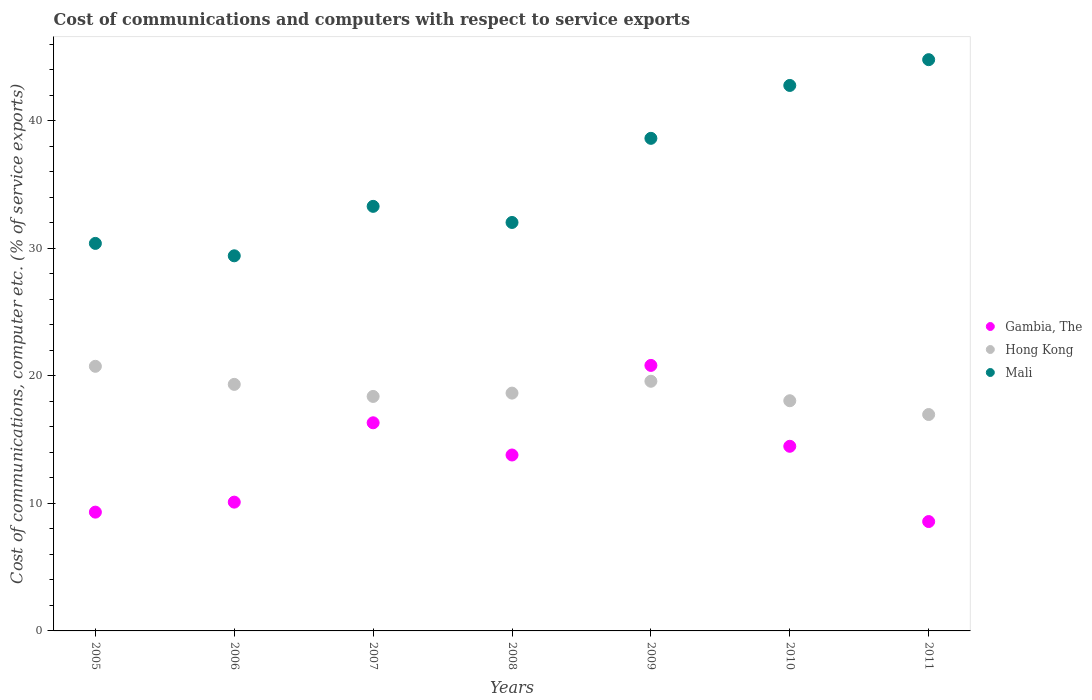How many different coloured dotlines are there?
Your answer should be very brief. 3. Is the number of dotlines equal to the number of legend labels?
Your answer should be very brief. Yes. What is the cost of communications and computers in Mali in 2008?
Offer a very short reply. 32.04. Across all years, what is the maximum cost of communications and computers in Gambia, The?
Give a very brief answer. 20.83. Across all years, what is the minimum cost of communications and computers in Gambia, The?
Offer a terse response. 8.58. In which year was the cost of communications and computers in Gambia, The maximum?
Provide a succinct answer. 2009. What is the total cost of communications and computers in Mali in the graph?
Make the answer very short. 251.39. What is the difference between the cost of communications and computers in Gambia, The in 2005 and that in 2009?
Offer a very short reply. -11.51. What is the difference between the cost of communications and computers in Hong Kong in 2006 and the cost of communications and computers in Gambia, The in 2011?
Provide a short and direct response. 10.76. What is the average cost of communications and computers in Hong Kong per year?
Offer a terse response. 18.82. In the year 2009, what is the difference between the cost of communications and computers in Gambia, The and cost of communications and computers in Hong Kong?
Keep it short and to the point. 1.24. What is the ratio of the cost of communications and computers in Hong Kong in 2007 to that in 2011?
Ensure brevity in your answer.  1.08. Is the cost of communications and computers in Gambia, The in 2008 less than that in 2011?
Provide a succinct answer. No. What is the difference between the highest and the second highest cost of communications and computers in Gambia, The?
Give a very brief answer. 4.5. What is the difference between the highest and the lowest cost of communications and computers in Hong Kong?
Your answer should be compact. 3.78. Is the cost of communications and computers in Hong Kong strictly less than the cost of communications and computers in Mali over the years?
Your answer should be compact. Yes. How many years are there in the graph?
Your answer should be very brief. 7. Does the graph contain grids?
Your answer should be very brief. No. Where does the legend appear in the graph?
Ensure brevity in your answer.  Center right. How are the legend labels stacked?
Provide a succinct answer. Vertical. What is the title of the graph?
Provide a succinct answer. Cost of communications and computers with respect to service exports. What is the label or title of the Y-axis?
Ensure brevity in your answer.  Cost of communications, computer etc. (% of service exports). What is the Cost of communications, computer etc. (% of service exports) of Gambia, The in 2005?
Your response must be concise. 9.32. What is the Cost of communications, computer etc. (% of service exports) of Hong Kong in 2005?
Offer a very short reply. 20.76. What is the Cost of communications, computer etc. (% of service exports) in Mali in 2005?
Your answer should be very brief. 30.4. What is the Cost of communications, computer etc. (% of service exports) of Gambia, The in 2006?
Your answer should be very brief. 10.1. What is the Cost of communications, computer etc. (% of service exports) in Hong Kong in 2006?
Provide a succinct answer. 19.34. What is the Cost of communications, computer etc. (% of service exports) in Mali in 2006?
Make the answer very short. 29.42. What is the Cost of communications, computer etc. (% of service exports) in Gambia, The in 2007?
Provide a short and direct response. 16.33. What is the Cost of communications, computer etc. (% of service exports) of Hong Kong in 2007?
Give a very brief answer. 18.39. What is the Cost of communications, computer etc. (% of service exports) of Mali in 2007?
Offer a very short reply. 33.3. What is the Cost of communications, computer etc. (% of service exports) in Gambia, The in 2008?
Offer a very short reply. 13.8. What is the Cost of communications, computer etc. (% of service exports) in Hong Kong in 2008?
Your answer should be very brief. 18.65. What is the Cost of communications, computer etc. (% of service exports) in Mali in 2008?
Your answer should be compact. 32.04. What is the Cost of communications, computer etc. (% of service exports) of Gambia, The in 2009?
Ensure brevity in your answer.  20.83. What is the Cost of communications, computer etc. (% of service exports) of Hong Kong in 2009?
Provide a short and direct response. 19.58. What is the Cost of communications, computer etc. (% of service exports) in Mali in 2009?
Your response must be concise. 38.64. What is the Cost of communications, computer etc. (% of service exports) in Gambia, The in 2010?
Your answer should be very brief. 14.48. What is the Cost of communications, computer etc. (% of service exports) in Hong Kong in 2010?
Give a very brief answer. 18.06. What is the Cost of communications, computer etc. (% of service exports) of Mali in 2010?
Your response must be concise. 42.79. What is the Cost of communications, computer etc. (% of service exports) in Gambia, The in 2011?
Your answer should be compact. 8.58. What is the Cost of communications, computer etc. (% of service exports) of Hong Kong in 2011?
Keep it short and to the point. 16.97. What is the Cost of communications, computer etc. (% of service exports) in Mali in 2011?
Offer a terse response. 44.81. Across all years, what is the maximum Cost of communications, computer etc. (% of service exports) of Gambia, The?
Your answer should be compact. 20.83. Across all years, what is the maximum Cost of communications, computer etc. (% of service exports) of Hong Kong?
Make the answer very short. 20.76. Across all years, what is the maximum Cost of communications, computer etc. (% of service exports) of Mali?
Offer a terse response. 44.81. Across all years, what is the minimum Cost of communications, computer etc. (% of service exports) in Gambia, The?
Offer a terse response. 8.58. Across all years, what is the minimum Cost of communications, computer etc. (% of service exports) of Hong Kong?
Provide a short and direct response. 16.97. Across all years, what is the minimum Cost of communications, computer etc. (% of service exports) in Mali?
Ensure brevity in your answer.  29.42. What is the total Cost of communications, computer etc. (% of service exports) of Gambia, The in the graph?
Your answer should be very brief. 93.43. What is the total Cost of communications, computer etc. (% of service exports) in Hong Kong in the graph?
Ensure brevity in your answer.  131.75. What is the total Cost of communications, computer etc. (% of service exports) in Mali in the graph?
Your answer should be very brief. 251.39. What is the difference between the Cost of communications, computer etc. (% of service exports) in Gambia, The in 2005 and that in 2006?
Keep it short and to the point. -0.78. What is the difference between the Cost of communications, computer etc. (% of service exports) of Hong Kong in 2005 and that in 2006?
Ensure brevity in your answer.  1.42. What is the difference between the Cost of communications, computer etc. (% of service exports) in Mali in 2005 and that in 2006?
Offer a terse response. 0.97. What is the difference between the Cost of communications, computer etc. (% of service exports) of Gambia, The in 2005 and that in 2007?
Give a very brief answer. -7.01. What is the difference between the Cost of communications, computer etc. (% of service exports) in Hong Kong in 2005 and that in 2007?
Your answer should be very brief. 2.36. What is the difference between the Cost of communications, computer etc. (% of service exports) of Mali in 2005 and that in 2007?
Ensure brevity in your answer.  -2.91. What is the difference between the Cost of communications, computer etc. (% of service exports) in Gambia, The in 2005 and that in 2008?
Your answer should be very brief. -4.48. What is the difference between the Cost of communications, computer etc. (% of service exports) of Hong Kong in 2005 and that in 2008?
Provide a succinct answer. 2.1. What is the difference between the Cost of communications, computer etc. (% of service exports) in Mali in 2005 and that in 2008?
Provide a short and direct response. -1.64. What is the difference between the Cost of communications, computer etc. (% of service exports) in Gambia, The in 2005 and that in 2009?
Give a very brief answer. -11.51. What is the difference between the Cost of communications, computer etc. (% of service exports) of Hong Kong in 2005 and that in 2009?
Provide a succinct answer. 1.17. What is the difference between the Cost of communications, computer etc. (% of service exports) in Mali in 2005 and that in 2009?
Provide a succinct answer. -8.24. What is the difference between the Cost of communications, computer etc. (% of service exports) in Gambia, The in 2005 and that in 2010?
Your answer should be very brief. -5.16. What is the difference between the Cost of communications, computer etc. (% of service exports) in Hong Kong in 2005 and that in 2010?
Provide a succinct answer. 2.7. What is the difference between the Cost of communications, computer etc. (% of service exports) of Mali in 2005 and that in 2010?
Provide a short and direct response. -12.39. What is the difference between the Cost of communications, computer etc. (% of service exports) in Gambia, The in 2005 and that in 2011?
Provide a succinct answer. 0.74. What is the difference between the Cost of communications, computer etc. (% of service exports) in Hong Kong in 2005 and that in 2011?
Offer a terse response. 3.78. What is the difference between the Cost of communications, computer etc. (% of service exports) of Mali in 2005 and that in 2011?
Your answer should be very brief. -14.41. What is the difference between the Cost of communications, computer etc. (% of service exports) of Gambia, The in 2006 and that in 2007?
Keep it short and to the point. -6.22. What is the difference between the Cost of communications, computer etc. (% of service exports) in Hong Kong in 2006 and that in 2007?
Your answer should be very brief. 0.95. What is the difference between the Cost of communications, computer etc. (% of service exports) of Mali in 2006 and that in 2007?
Provide a succinct answer. -3.88. What is the difference between the Cost of communications, computer etc. (% of service exports) of Gambia, The in 2006 and that in 2008?
Give a very brief answer. -3.7. What is the difference between the Cost of communications, computer etc. (% of service exports) in Hong Kong in 2006 and that in 2008?
Ensure brevity in your answer.  0.68. What is the difference between the Cost of communications, computer etc. (% of service exports) of Mali in 2006 and that in 2008?
Your answer should be very brief. -2.62. What is the difference between the Cost of communications, computer etc. (% of service exports) of Gambia, The in 2006 and that in 2009?
Your answer should be very brief. -10.72. What is the difference between the Cost of communications, computer etc. (% of service exports) in Hong Kong in 2006 and that in 2009?
Your answer should be very brief. -0.25. What is the difference between the Cost of communications, computer etc. (% of service exports) in Mali in 2006 and that in 2009?
Your answer should be compact. -9.21. What is the difference between the Cost of communications, computer etc. (% of service exports) in Gambia, The in 2006 and that in 2010?
Offer a very short reply. -4.38. What is the difference between the Cost of communications, computer etc. (% of service exports) of Hong Kong in 2006 and that in 2010?
Offer a terse response. 1.28. What is the difference between the Cost of communications, computer etc. (% of service exports) in Mali in 2006 and that in 2010?
Provide a succinct answer. -13.36. What is the difference between the Cost of communications, computer etc. (% of service exports) in Gambia, The in 2006 and that in 2011?
Provide a short and direct response. 1.52. What is the difference between the Cost of communications, computer etc. (% of service exports) in Hong Kong in 2006 and that in 2011?
Your answer should be very brief. 2.36. What is the difference between the Cost of communications, computer etc. (% of service exports) in Mali in 2006 and that in 2011?
Your response must be concise. -15.38. What is the difference between the Cost of communications, computer etc. (% of service exports) of Gambia, The in 2007 and that in 2008?
Give a very brief answer. 2.53. What is the difference between the Cost of communications, computer etc. (% of service exports) of Hong Kong in 2007 and that in 2008?
Give a very brief answer. -0.26. What is the difference between the Cost of communications, computer etc. (% of service exports) of Mali in 2007 and that in 2008?
Give a very brief answer. 1.26. What is the difference between the Cost of communications, computer etc. (% of service exports) in Gambia, The in 2007 and that in 2009?
Ensure brevity in your answer.  -4.5. What is the difference between the Cost of communications, computer etc. (% of service exports) in Hong Kong in 2007 and that in 2009?
Ensure brevity in your answer.  -1.19. What is the difference between the Cost of communications, computer etc. (% of service exports) of Mali in 2007 and that in 2009?
Keep it short and to the point. -5.33. What is the difference between the Cost of communications, computer etc. (% of service exports) of Gambia, The in 2007 and that in 2010?
Offer a very short reply. 1.84. What is the difference between the Cost of communications, computer etc. (% of service exports) of Hong Kong in 2007 and that in 2010?
Provide a succinct answer. 0.34. What is the difference between the Cost of communications, computer etc. (% of service exports) of Mali in 2007 and that in 2010?
Ensure brevity in your answer.  -9.48. What is the difference between the Cost of communications, computer etc. (% of service exports) of Gambia, The in 2007 and that in 2011?
Make the answer very short. 7.75. What is the difference between the Cost of communications, computer etc. (% of service exports) of Hong Kong in 2007 and that in 2011?
Make the answer very short. 1.42. What is the difference between the Cost of communications, computer etc. (% of service exports) of Mali in 2007 and that in 2011?
Provide a succinct answer. -11.51. What is the difference between the Cost of communications, computer etc. (% of service exports) of Gambia, The in 2008 and that in 2009?
Your answer should be compact. -7.03. What is the difference between the Cost of communications, computer etc. (% of service exports) of Hong Kong in 2008 and that in 2009?
Ensure brevity in your answer.  -0.93. What is the difference between the Cost of communications, computer etc. (% of service exports) in Mali in 2008 and that in 2009?
Give a very brief answer. -6.6. What is the difference between the Cost of communications, computer etc. (% of service exports) in Gambia, The in 2008 and that in 2010?
Your response must be concise. -0.68. What is the difference between the Cost of communications, computer etc. (% of service exports) of Hong Kong in 2008 and that in 2010?
Your answer should be compact. 0.6. What is the difference between the Cost of communications, computer etc. (% of service exports) in Mali in 2008 and that in 2010?
Offer a terse response. -10.75. What is the difference between the Cost of communications, computer etc. (% of service exports) in Gambia, The in 2008 and that in 2011?
Offer a terse response. 5.22. What is the difference between the Cost of communications, computer etc. (% of service exports) in Hong Kong in 2008 and that in 2011?
Your response must be concise. 1.68. What is the difference between the Cost of communications, computer etc. (% of service exports) in Mali in 2008 and that in 2011?
Give a very brief answer. -12.77. What is the difference between the Cost of communications, computer etc. (% of service exports) in Gambia, The in 2009 and that in 2010?
Keep it short and to the point. 6.34. What is the difference between the Cost of communications, computer etc. (% of service exports) of Hong Kong in 2009 and that in 2010?
Your response must be concise. 1.53. What is the difference between the Cost of communications, computer etc. (% of service exports) in Mali in 2009 and that in 2010?
Ensure brevity in your answer.  -4.15. What is the difference between the Cost of communications, computer etc. (% of service exports) in Gambia, The in 2009 and that in 2011?
Give a very brief answer. 12.25. What is the difference between the Cost of communications, computer etc. (% of service exports) in Hong Kong in 2009 and that in 2011?
Keep it short and to the point. 2.61. What is the difference between the Cost of communications, computer etc. (% of service exports) in Mali in 2009 and that in 2011?
Your answer should be compact. -6.17. What is the difference between the Cost of communications, computer etc. (% of service exports) of Gambia, The in 2010 and that in 2011?
Provide a short and direct response. 5.9. What is the difference between the Cost of communications, computer etc. (% of service exports) of Hong Kong in 2010 and that in 2011?
Provide a short and direct response. 1.08. What is the difference between the Cost of communications, computer etc. (% of service exports) of Mali in 2010 and that in 2011?
Ensure brevity in your answer.  -2.02. What is the difference between the Cost of communications, computer etc. (% of service exports) in Gambia, The in 2005 and the Cost of communications, computer etc. (% of service exports) in Hong Kong in 2006?
Offer a terse response. -10.02. What is the difference between the Cost of communications, computer etc. (% of service exports) of Gambia, The in 2005 and the Cost of communications, computer etc. (% of service exports) of Mali in 2006?
Make the answer very short. -20.11. What is the difference between the Cost of communications, computer etc. (% of service exports) of Hong Kong in 2005 and the Cost of communications, computer etc. (% of service exports) of Mali in 2006?
Ensure brevity in your answer.  -8.67. What is the difference between the Cost of communications, computer etc. (% of service exports) in Gambia, The in 2005 and the Cost of communications, computer etc. (% of service exports) in Hong Kong in 2007?
Ensure brevity in your answer.  -9.08. What is the difference between the Cost of communications, computer etc. (% of service exports) in Gambia, The in 2005 and the Cost of communications, computer etc. (% of service exports) in Mali in 2007?
Provide a short and direct response. -23.98. What is the difference between the Cost of communications, computer etc. (% of service exports) of Hong Kong in 2005 and the Cost of communications, computer etc. (% of service exports) of Mali in 2007?
Make the answer very short. -12.55. What is the difference between the Cost of communications, computer etc. (% of service exports) of Gambia, The in 2005 and the Cost of communications, computer etc. (% of service exports) of Hong Kong in 2008?
Provide a succinct answer. -9.34. What is the difference between the Cost of communications, computer etc. (% of service exports) of Gambia, The in 2005 and the Cost of communications, computer etc. (% of service exports) of Mali in 2008?
Keep it short and to the point. -22.72. What is the difference between the Cost of communications, computer etc. (% of service exports) of Hong Kong in 2005 and the Cost of communications, computer etc. (% of service exports) of Mali in 2008?
Provide a succinct answer. -11.28. What is the difference between the Cost of communications, computer etc. (% of service exports) of Gambia, The in 2005 and the Cost of communications, computer etc. (% of service exports) of Hong Kong in 2009?
Your answer should be compact. -10.27. What is the difference between the Cost of communications, computer etc. (% of service exports) of Gambia, The in 2005 and the Cost of communications, computer etc. (% of service exports) of Mali in 2009?
Your answer should be very brief. -29.32. What is the difference between the Cost of communications, computer etc. (% of service exports) of Hong Kong in 2005 and the Cost of communications, computer etc. (% of service exports) of Mali in 2009?
Your answer should be compact. -17.88. What is the difference between the Cost of communications, computer etc. (% of service exports) in Gambia, The in 2005 and the Cost of communications, computer etc. (% of service exports) in Hong Kong in 2010?
Give a very brief answer. -8.74. What is the difference between the Cost of communications, computer etc. (% of service exports) of Gambia, The in 2005 and the Cost of communications, computer etc. (% of service exports) of Mali in 2010?
Your response must be concise. -33.47. What is the difference between the Cost of communications, computer etc. (% of service exports) in Hong Kong in 2005 and the Cost of communications, computer etc. (% of service exports) in Mali in 2010?
Your answer should be compact. -22.03. What is the difference between the Cost of communications, computer etc. (% of service exports) in Gambia, The in 2005 and the Cost of communications, computer etc. (% of service exports) in Hong Kong in 2011?
Provide a short and direct response. -7.66. What is the difference between the Cost of communications, computer etc. (% of service exports) in Gambia, The in 2005 and the Cost of communications, computer etc. (% of service exports) in Mali in 2011?
Offer a terse response. -35.49. What is the difference between the Cost of communications, computer etc. (% of service exports) in Hong Kong in 2005 and the Cost of communications, computer etc. (% of service exports) in Mali in 2011?
Give a very brief answer. -24.05. What is the difference between the Cost of communications, computer etc. (% of service exports) of Gambia, The in 2006 and the Cost of communications, computer etc. (% of service exports) of Hong Kong in 2007?
Your response must be concise. -8.29. What is the difference between the Cost of communications, computer etc. (% of service exports) in Gambia, The in 2006 and the Cost of communications, computer etc. (% of service exports) in Mali in 2007?
Offer a terse response. -23.2. What is the difference between the Cost of communications, computer etc. (% of service exports) of Hong Kong in 2006 and the Cost of communications, computer etc. (% of service exports) of Mali in 2007?
Your answer should be very brief. -13.96. What is the difference between the Cost of communications, computer etc. (% of service exports) of Gambia, The in 2006 and the Cost of communications, computer etc. (% of service exports) of Hong Kong in 2008?
Keep it short and to the point. -8.55. What is the difference between the Cost of communications, computer etc. (% of service exports) of Gambia, The in 2006 and the Cost of communications, computer etc. (% of service exports) of Mali in 2008?
Keep it short and to the point. -21.94. What is the difference between the Cost of communications, computer etc. (% of service exports) in Hong Kong in 2006 and the Cost of communications, computer etc. (% of service exports) in Mali in 2008?
Offer a terse response. -12.7. What is the difference between the Cost of communications, computer etc. (% of service exports) in Gambia, The in 2006 and the Cost of communications, computer etc. (% of service exports) in Hong Kong in 2009?
Give a very brief answer. -9.48. What is the difference between the Cost of communications, computer etc. (% of service exports) of Gambia, The in 2006 and the Cost of communications, computer etc. (% of service exports) of Mali in 2009?
Your answer should be compact. -28.54. What is the difference between the Cost of communications, computer etc. (% of service exports) in Hong Kong in 2006 and the Cost of communications, computer etc. (% of service exports) in Mali in 2009?
Ensure brevity in your answer.  -19.3. What is the difference between the Cost of communications, computer etc. (% of service exports) of Gambia, The in 2006 and the Cost of communications, computer etc. (% of service exports) of Hong Kong in 2010?
Offer a terse response. -7.95. What is the difference between the Cost of communications, computer etc. (% of service exports) in Gambia, The in 2006 and the Cost of communications, computer etc. (% of service exports) in Mali in 2010?
Offer a terse response. -32.68. What is the difference between the Cost of communications, computer etc. (% of service exports) of Hong Kong in 2006 and the Cost of communications, computer etc. (% of service exports) of Mali in 2010?
Offer a terse response. -23.45. What is the difference between the Cost of communications, computer etc. (% of service exports) of Gambia, The in 2006 and the Cost of communications, computer etc. (% of service exports) of Hong Kong in 2011?
Offer a very short reply. -6.87. What is the difference between the Cost of communications, computer etc. (% of service exports) in Gambia, The in 2006 and the Cost of communications, computer etc. (% of service exports) in Mali in 2011?
Your answer should be very brief. -34.71. What is the difference between the Cost of communications, computer etc. (% of service exports) of Hong Kong in 2006 and the Cost of communications, computer etc. (% of service exports) of Mali in 2011?
Give a very brief answer. -25.47. What is the difference between the Cost of communications, computer etc. (% of service exports) in Gambia, The in 2007 and the Cost of communications, computer etc. (% of service exports) in Hong Kong in 2008?
Your response must be concise. -2.33. What is the difference between the Cost of communications, computer etc. (% of service exports) in Gambia, The in 2007 and the Cost of communications, computer etc. (% of service exports) in Mali in 2008?
Your response must be concise. -15.71. What is the difference between the Cost of communications, computer etc. (% of service exports) of Hong Kong in 2007 and the Cost of communications, computer etc. (% of service exports) of Mali in 2008?
Offer a very short reply. -13.65. What is the difference between the Cost of communications, computer etc. (% of service exports) in Gambia, The in 2007 and the Cost of communications, computer etc. (% of service exports) in Hong Kong in 2009?
Provide a short and direct response. -3.26. What is the difference between the Cost of communications, computer etc. (% of service exports) in Gambia, The in 2007 and the Cost of communications, computer etc. (% of service exports) in Mali in 2009?
Your answer should be compact. -22.31. What is the difference between the Cost of communications, computer etc. (% of service exports) of Hong Kong in 2007 and the Cost of communications, computer etc. (% of service exports) of Mali in 2009?
Keep it short and to the point. -20.24. What is the difference between the Cost of communications, computer etc. (% of service exports) of Gambia, The in 2007 and the Cost of communications, computer etc. (% of service exports) of Hong Kong in 2010?
Provide a short and direct response. -1.73. What is the difference between the Cost of communications, computer etc. (% of service exports) in Gambia, The in 2007 and the Cost of communications, computer etc. (% of service exports) in Mali in 2010?
Provide a short and direct response. -26.46. What is the difference between the Cost of communications, computer etc. (% of service exports) in Hong Kong in 2007 and the Cost of communications, computer etc. (% of service exports) in Mali in 2010?
Your answer should be very brief. -24.39. What is the difference between the Cost of communications, computer etc. (% of service exports) of Gambia, The in 2007 and the Cost of communications, computer etc. (% of service exports) of Hong Kong in 2011?
Ensure brevity in your answer.  -0.65. What is the difference between the Cost of communications, computer etc. (% of service exports) of Gambia, The in 2007 and the Cost of communications, computer etc. (% of service exports) of Mali in 2011?
Offer a terse response. -28.48. What is the difference between the Cost of communications, computer etc. (% of service exports) in Hong Kong in 2007 and the Cost of communications, computer etc. (% of service exports) in Mali in 2011?
Keep it short and to the point. -26.41. What is the difference between the Cost of communications, computer etc. (% of service exports) of Gambia, The in 2008 and the Cost of communications, computer etc. (% of service exports) of Hong Kong in 2009?
Your answer should be very brief. -5.78. What is the difference between the Cost of communications, computer etc. (% of service exports) of Gambia, The in 2008 and the Cost of communications, computer etc. (% of service exports) of Mali in 2009?
Make the answer very short. -24.84. What is the difference between the Cost of communications, computer etc. (% of service exports) in Hong Kong in 2008 and the Cost of communications, computer etc. (% of service exports) in Mali in 2009?
Your answer should be compact. -19.98. What is the difference between the Cost of communications, computer etc. (% of service exports) in Gambia, The in 2008 and the Cost of communications, computer etc. (% of service exports) in Hong Kong in 2010?
Your answer should be very brief. -4.26. What is the difference between the Cost of communications, computer etc. (% of service exports) of Gambia, The in 2008 and the Cost of communications, computer etc. (% of service exports) of Mali in 2010?
Your answer should be compact. -28.99. What is the difference between the Cost of communications, computer etc. (% of service exports) in Hong Kong in 2008 and the Cost of communications, computer etc. (% of service exports) in Mali in 2010?
Your response must be concise. -24.13. What is the difference between the Cost of communications, computer etc. (% of service exports) of Gambia, The in 2008 and the Cost of communications, computer etc. (% of service exports) of Hong Kong in 2011?
Give a very brief answer. -3.17. What is the difference between the Cost of communications, computer etc. (% of service exports) of Gambia, The in 2008 and the Cost of communications, computer etc. (% of service exports) of Mali in 2011?
Offer a terse response. -31.01. What is the difference between the Cost of communications, computer etc. (% of service exports) of Hong Kong in 2008 and the Cost of communications, computer etc. (% of service exports) of Mali in 2011?
Your answer should be compact. -26.15. What is the difference between the Cost of communications, computer etc. (% of service exports) of Gambia, The in 2009 and the Cost of communications, computer etc. (% of service exports) of Hong Kong in 2010?
Your response must be concise. 2.77. What is the difference between the Cost of communications, computer etc. (% of service exports) in Gambia, The in 2009 and the Cost of communications, computer etc. (% of service exports) in Mali in 2010?
Make the answer very short. -21.96. What is the difference between the Cost of communications, computer etc. (% of service exports) of Hong Kong in 2009 and the Cost of communications, computer etc. (% of service exports) of Mali in 2010?
Provide a succinct answer. -23.2. What is the difference between the Cost of communications, computer etc. (% of service exports) of Gambia, The in 2009 and the Cost of communications, computer etc. (% of service exports) of Hong Kong in 2011?
Offer a very short reply. 3.85. What is the difference between the Cost of communications, computer etc. (% of service exports) of Gambia, The in 2009 and the Cost of communications, computer etc. (% of service exports) of Mali in 2011?
Give a very brief answer. -23.98. What is the difference between the Cost of communications, computer etc. (% of service exports) in Hong Kong in 2009 and the Cost of communications, computer etc. (% of service exports) in Mali in 2011?
Your answer should be very brief. -25.22. What is the difference between the Cost of communications, computer etc. (% of service exports) in Gambia, The in 2010 and the Cost of communications, computer etc. (% of service exports) in Hong Kong in 2011?
Ensure brevity in your answer.  -2.49. What is the difference between the Cost of communications, computer etc. (% of service exports) in Gambia, The in 2010 and the Cost of communications, computer etc. (% of service exports) in Mali in 2011?
Ensure brevity in your answer.  -30.33. What is the difference between the Cost of communications, computer etc. (% of service exports) in Hong Kong in 2010 and the Cost of communications, computer etc. (% of service exports) in Mali in 2011?
Provide a short and direct response. -26.75. What is the average Cost of communications, computer etc. (% of service exports) in Gambia, The per year?
Provide a short and direct response. 13.35. What is the average Cost of communications, computer etc. (% of service exports) in Hong Kong per year?
Offer a very short reply. 18.82. What is the average Cost of communications, computer etc. (% of service exports) of Mali per year?
Your answer should be compact. 35.91. In the year 2005, what is the difference between the Cost of communications, computer etc. (% of service exports) in Gambia, The and Cost of communications, computer etc. (% of service exports) in Hong Kong?
Give a very brief answer. -11.44. In the year 2005, what is the difference between the Cost of communications, computer etc. (% of service exports) of Gambia, The and Cost of communications, computer etc. (% of service exports) of Mali?
Your response must be concise. -21.08. In the year 2005, what is the difference between the Cost of communications, computer etc. (% of service exports) in Hong Kong and Cost of communications, computer etc. (% of service exports) in Mali?
Your answer should be compact. -9.64. In the year 2006, what is the difference between the Cost of communications, computer etc. (% of service exports) of Gambia, The and Cost of communications, computer etc. (% of service exports) of Hong Kong?
Provide a short and direct response. -9.24. In the year 2006, what is the difference between the Cost of communications, computer etc. (% of service exports) in Gambia, The and Cost of communications, computer etc. (% of service exports) in Mali?
Offer a terse response. -19.32. In the year 2006, what is the difference between the Cost of communications, computer etc. (% of service exports) of Hong Kong and Cost of communications, computer etc. (% of service exports) of Mali?
Make the answer very short. -10.09. In the year 2007, what is the difference between the Cost of communications, computer etc. (% of service exports) of Gambia, The and Cost of communications, computer etc. (% of service exports) of Hong Kong?
Offer a terse response. -2.07. In the year 2007, what is the difference between the Cost of communications, computer etc. (% of service exports) in Gambia, The and Cost of communications, computer etc. (% of service exports) in Mali?
Your answer should be compact. -16.98. In the year 2007, what is the difference between the Cost of communications, computer etc. (% of service exports) in Hong Kong and Cost of communications, computer etc. (% of service exports) in Mali?
Your response must be concise. -14.91. In the year 2008, what is the difference between the Cost of communications, computer etc. (% of service exports) of Gambia, The and Cost of communications, computer etc. (% of service exports) of Hong Kong?
Make the answer very short. -4.85. In the year 2008, what is the difference between the Cost of communications, computer etc. (% of service exports) of Gambia, The and Cost of communications, computer etc. (% of service exports) of Mali?
Offer a terse response. -18.24. In the year 2008, what is the difference between the Cost of communications, computer etc. (% of service exports) of Hong Kong and Cost of communications, computer etc. (% of service exports) of Mali?
Offer a terse response. -13.38. In the year 2009, what is the difference between the Cost of communications, computer etc. (% of service exports) of Gambia, The and Cost of communications, computer etc. (% of service exports) of Hong Kong?
Make the answer very short. 1.24. In the year 2009, what is the difference between the Cost of communications, computer etc. (% of service exports) in Gambia, The and Cost of communications, computer etc. (% of service exports) in Mali?
Offer a very short reply. -17.81. In the year 2009, what is the difference between the Cost of communications, computer etc. (% of service exports) in Hong Kong and Cost of communications, computer etc. (% of service exports) in Mali?
Your response must be concise. -19.05. In the year 2010, what is the difference between the Cost of communications, computer etc. (% of service exports) of Gambia, The and Cost of communications, computer etc. (% of service exports) of Hong Kong?
Keep it short and to the point. -3.57. In the year 2010, what is the difference between the Cost of communications, computer etc. (% of service exports) in Gambia, The and Cost of communications, computer etc. (% of service exports) in Mali?
Ensure brevity in your answer.  -28.3. In the year 2010, what is the difference between the Cost of communications, computer etc. (% of service exports) of Hong Kong and Cost of communications, computer etc. (% of service exports) of Mali?
Provide a succinct answer. -24.73. In the year 2011, what is the difference between the Cost of communications, computer etc. (% of service exports) of Gambia, The and Cost of communications, computer etc. (% of service exports) of Hong Kong?
Give a very brief answer. -8.4. In the year 2011, what is the difference between the Cost of communications, computer etc. (% of service exports) in Gambia, The and Cost of communications, computer etc. (% of service exports) in Mali?
Your answer should be very brief. -36.23. In the year 2011, what is the difference between the Cost of communications, computer etc. (% of service exports) in Hong Kong and Cost of communications, computer etc. (% of service exports) in Mali?
Your response must be concise. -27.83. What is the ratio of the Cost of communications, computer etc. (% of service exports) of Gambia, The in 2005 to that in 2006?
Your response must be concise. 0.92. What is the ratio of the Cost of communications, computer etc. (% of service exports) of Hong Kong in 2005 to that in 2006?
Keep it short and to the point. 1.07. What is the ratio of the Cost of communications, computer etc. (% of service exports) of Mali in 2005 to that in 2006?
Your answer should be compact. 1.03. What is the ratio of the Cost of communications, computer etc. (% of service exports) of Gambia, The in 2005 to that in 2007?
Keep it short and to the point. 0.57. What is the ratio of the Cost of communications, computer etc. (% of service exports) in Hong Kong in 2005 to that in 2007?
Your response must be concise. 1.13. What is the ratio of the Cost of communications, computer etc. (% of service exports) of Mali in 2005 to that in 2007?
Your answer should be very brief. 0.91. What is the ratio of the Cost of communications, computer etc. (% of service exports) of Gambia, The in 2005 to that in 2008?
Give a very brief answer. 0.68. What is the ratio of the Cost of communications, computer etc. (% of service exports) of Hong Kong in 2005 to that in 2008?
Give a very brief answer. 1.11. What is the ratio of the Cost of communications, computer etc. (% of service exports) of Mali in 2005 to that in 2008?
Your answer should be compact. 0.95. What is the ratio of the Cost of communications, computer etc. (% of service exports) of Gambia, The in 2005 to that in 2009?
Your answer should be compact. 0.45. What is the ratio of the Cost of communications, computer etc. (% of service exports) of Hong Kong in 2005 to that in 2009?
Give a very brief answer. 1.06. What is the ratio of the Cost of communications, computer etc. (% of service exports) of Mali in 2005 to that in 2009?
Ensure brevity in your answer.  0.79. What is the ratio of the Cost of communications, computer etc. (% of service exports) of Gambia, The in 2005 to that in 2010?
Your answer should be compact. 0.64. What is the ratio of the Cost of communications, computer etc. (% of service exports) of Hong Kong in 2005 to that in 2010?
Your answer should be very brief. 1.15. What is the ratio of the Cost of communications, computer etc. (% of service exports) of Mali in 2005 to that in 2010?
Provide a succinct answer. 0.71. What is the ratio of the Cost of communications, computer etc. (% of service exports) in Gambia, The in 2005 to that in 2011?
Offer a terse response. 1.09. What is the ratio of the Cost of communications, computer etc. (% of service exports) in Hong Kong in 2005 to that in 2011?
Keep it short and to the point. 1.22. What is the ratio of the Cost of communications, computer etc. (% of service exports) in Mali in 2005 to that in 2011?
Your answer should be compact. 0.68. What is the ratio of the Cost of communications, computer etc. (% of service exports) in Gambia, The in 2006 to that in 2007?
Your answer should be compact. 0.62. What is the ratio of the Cost of communications, computer etc. (% of service exports) in Hong Kong in 2006 to that in 2007?
Make the answer very short. 1.05. What is the ratio of the Cost of communications, computer etc. (% of service exports) in Mali in 2006 to that in 2007?
Make the answer very short. 0.88. What is the ratio of the Cost of communications, computer etc. (% of service exports) in Gambia, The in 2006 to that in 2008?
Offer a very short reply. 0.73. What is the ratio of the Cost of communications, computer etc. (% of service exports) in Hong Kong in 2006 to that in 2008?
Provide a succinct answer. 1.04. What is the ratio of the Cost of communications, computer etc. (% of service exports) of Mali in 2006 to that in 2008?
Provide a short and direct response. 0.92. What is the ratio of the Cost of communications, computer etc. (% of service exports) in Gambia, The in 2006 to that in 2009?
Ensure brevity in your answer.  0.48. What is the ratio of the Cost of communications, computer etc. (% of service exports) in Hong Kong in 2006 to that in 2009?
Give a very brief answer. 0.99. What is the ratio of the Cost of communications, computer etc. (% of service exports) in Mali in 2006 to that in 2009?
Make the answer very short. 0.76. What is the ratio of the Cost of communications, computer etc. (% of service exports) of Gambia, The in 2006 to that in 2010?
Your response must be concise. 0.7. What is the ratio of the Cost of communications, computer etc. (% of service exports) in Hong Kong in 2006 to that in 2010?
Make the answer very short. 1.07. What is the ratio of the Cost of communications, computer etc. (% of service exports) in Mali in 2006 to that in 2010?
Your answer should be compact. 0.69. What is the ratio of the Cost of communications, computer etc. (% of service exports) of Gambia, The in 2006 to that in 2011?
Provide a succinct answer. 1.18. What is the ratio of the Cost of communications, computer etc. (% of service exports) in Hong Kong in 2006 to that in 2011?
Ensure brevity in your answer.  1.14. What is the ratio of the Cost of communications, computer etc. (% of service exports) of Mali in 2006 to that in 2011?
Your response must be concise. 0.66. What is the ratio of the Cost of communications, computer etc. (% of service exports) of Gambia, The in 2007 to that in 2008?
Your answer should be compact. 1.18. What is the ratio of the Cost of communications, computer etc. (% of service exports) in Mali in 2007 to that in 2008?
Give a very brief answer. 1.04. What is the ratio of the Cost of communications, computer etc. (% of service exports) in Gambia, The in 2007 to that in 2009?
Give a very brief answer. 0.78. What is the ratio of the Cost of communications, computer etc. (% of service exports) in Hong Kong in 2007 to that in 2009?
Your answer should be compact. 0.94. What is the ratio of the Cost of communications, computer etc. (% of service exports) in Mali in 2007 to that in 2009?
Ensure brevity in your answer.  0.86. What is the ratio of the Cost of communications, computer etc. (% of service exports) in Gambia, The in 2007 to that in 2010?
Provide a succinct answer. 1.13. What is the ratio of the Cost of communications, computer etc. (% of service exports) in Hong Kong in 2007 to that in 2010?
Keep it short and to the point. 1.02. What is the ratio of the Cost of communications, computer etc. (% of service exports) of Mali in 2007 to that in 2010?
Give a very brief answer. 0.78. What is the ratio of the Cost of communications, computer etc. (% of service exports) in Gambia, The in 2007 to that in 2011?
Provide a short and direct response. 1.9. What is the ratio of the Cost of communications, computer etc. (% of service exports) of Hong Kong in 2007 to that in 2011?
Ensure brevity in your answer.  1.08. What is the ratio of the Cost of communications, computer etc. (% of service exports) in Mali in 2007 to that in 2011?
Offer a very short reply. 0.74. What is the ratio of the Cost of communications, computer etc. (% of service exports) of Gambia, The in 2008 to that in 2009?
Make the answer very short. 0.66. What is the ratio of the Cost of communications, computer etc. (% of service exports) of Hong Kong in 2008 to that in 2009?
Offer a very short reply. 0.95. What is the ratio of the Cost of communications, computer etc. (% of service exports) of Mali in 2008 to that in 2009?
Keep it short and to the point. 0.83. What is the ratio of the Cost of communications, computer etc. (% of service exports) in Gambia, The in 2008 to that in 2010?
Your answer should be very brief. 0.95. What is the ratio of the Cost of communications, computer etc. (% of service exports) in Hong Kong in 2008 to that in 2010?
Provide a short and direct response. 1.03. What is the ratio of the Cost of communications, computer etc. (% of service exports) in Mali in 2008 to that in 2010?
Keep it short and to the point. 0.75. What is the ratio of the Cost of communications, computer etc. (% of service exports) in Gambia, The in 2008 to that in 2011?
Your response must be concise. 1.61. What is the ratio of the Cost of communications, computer etc. (% of service exports) in Hong Kong in 2008 to that in 2011?
Offer a terse response. 1.1. What is the ratio of the Cost of communications, computer etc. (% of service exports) of Mali in 2008 to that in 2011?
Provide a short and direct response. 0.71. What is the ratio of the Cost of communications, computer etc. (% of service exports) of Gambia, The in 2009 to that in 2010?
Provide a short and direct response. 1.44. What is the ratio of the Cost of communications, computer etc. (% of service exports) in Hong Kong in 2009 to that in 2010?
Your response must be concise. 1.08. What is the ratio of the Cost of communications, computer etc. (% of service exports) of Mali in 2009 to that in 2010?
Your answer should be compact. 0.9. What is the ratio of the Cost of communications, computer etc. (% of service exports) of Gambia, The in 2009 to that in 2011?
Your response must be concise. 2.43. What is the ratio of the Cost of communications, computer etc. (% of service exports) of Hong Kong in 2009 to that in 2011?
Ensure brevity in your answer.  1.15. What is the ratio of the Cost of communications, computer etc. (% of service exports) of Mali in 2009 to that in 2011?
Your response must be concise. 0.86. What is the ratio of the Cost of communications, computer etc. (% of service exports) in Gambia, The in 2010 to that in 2011?
Offer a terse response. 1.69. What is the ratio of the Cost of communications, computer etc. (% of service exports) in Hong Kong in 2010 to that in 2011?
Offer a very short reply. 1.06. What is the ratio of the Cost of communications, computer etc. (% of service exports) in Mali in 2010 to that in 2011?
Your answer should be compact. 0.95. What is the difference between the highest and the second highest Cost of communications, computer etc. (% of service exports) of Gambia, The?
Offer a terse response. 4.5. What is the difference between the highest and the second highest Cost of communications, computer etc. (% of service exports) in Hong Kong?
Give a very brief answer. 1.17. What is the difference between the highest and the second highest Cost of communications, computer etc. (% of service exports) of Mali?
Ensure brevity in your answer.  2.02. What is the difference between the highest and the lowest Cost of communications, computer etc. (% of service exports) of Gambia, The?
Your response must be concise. 12.25. What is the difference between the highest and the lowest Cost of communications, computer etc. (% of service exports) in Hong Kong?
Ensure brevity in your answer.  3.78. What is the difference between the highest and the lowest Cost of communications, computer etc. (% of service exports) of Mali?
Your answer should be very brief. 15.38. 